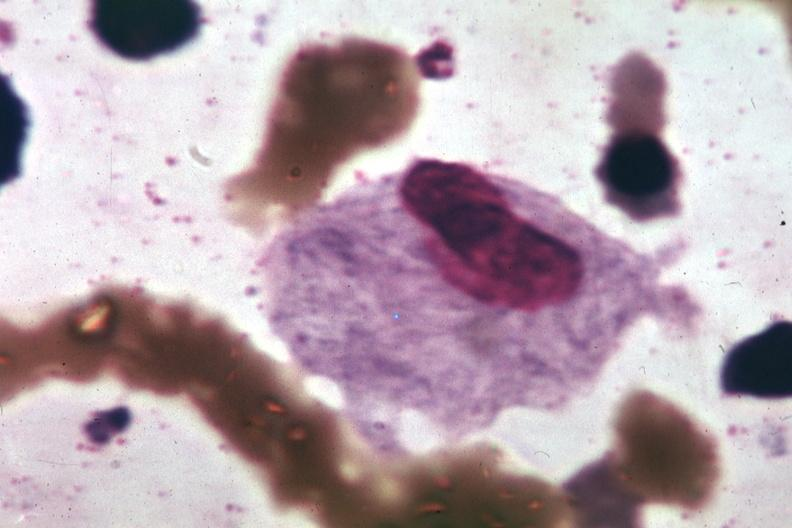s adenosis and ischemia present?
Answer the question using a single word or phrase. No 